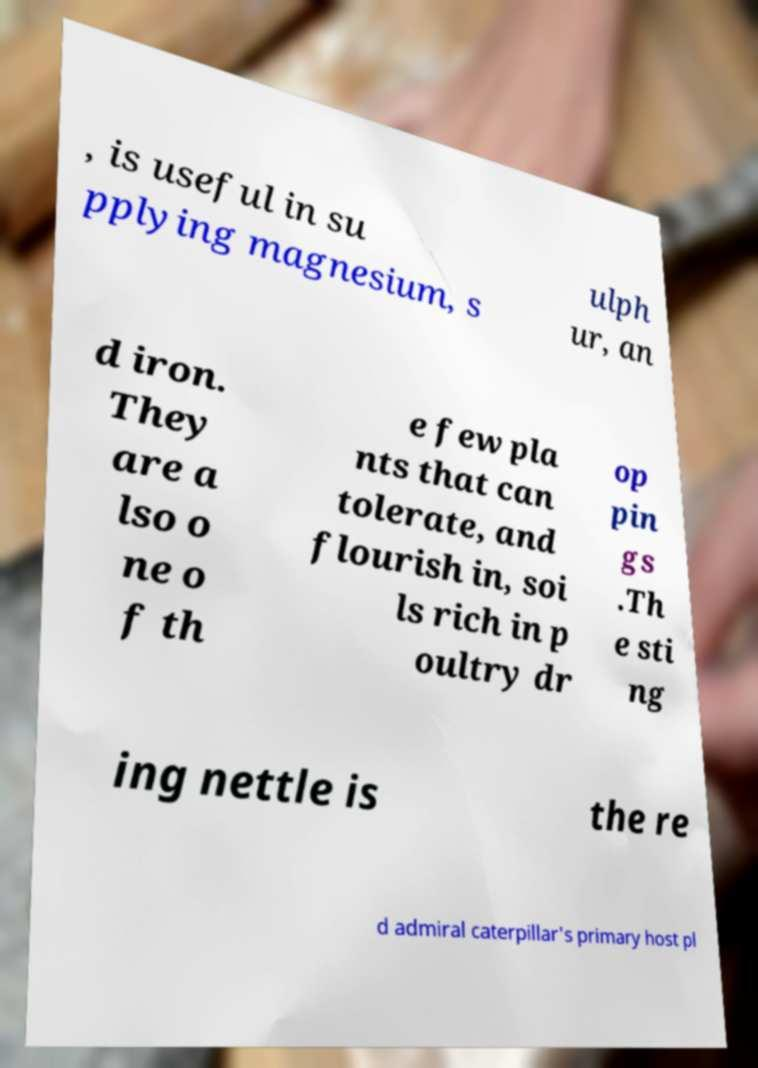For documentation purposes, I need the text within this image transcribed. Could you provide that? , is useful in su pplying magnesium, s ulph ur, an d iron. They are a lso o ne o f th e few pla nts that can tolerate, and flourish in, soi ls rich in p oultry dr op pin gs .Th e sti ng ing nettle is the re d admiral caterpillar's primary host pl 